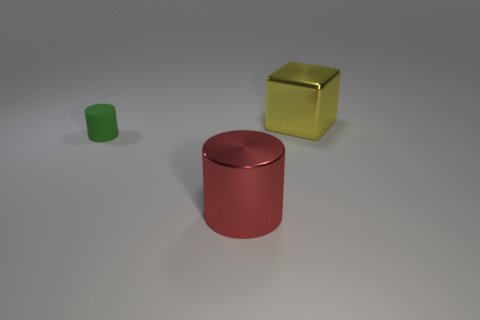How many other things are made of the same material as the big block?
Your answer should be very brief. 1. There is a object that is behind the red metallic cylinder and right of the small matte cylinder; what is its shape?
Make the answer very short. Cube. What is the color of the big block that is the same material as the red thing?
Your answer should be compact. Yellow. Is the number of big yellow metal objects right of the shiny cube the same as the number of big things?
Provide a succinct answer. No. What shape is the other object that is the same size as the red metallic object?
Offer a terse response. Cube. What number of other objects are the same shape as the green object?
Provide a short and direct response. 1. Is the size of the yellow block the same as the cylinder that is on the left side of the red cylinder?
Your answer should be compact. No. What number of objects are big metal objects that are to the left of the large yellow metallic object or small blue rubber cylinders?
Offer a terse response. 1. What shape is the big metal thing that is on the left side of the big yellow metal cube?
Provide a short and direct response. Cylinder. Is the number of large red things to the right of the big metal cube the same as the number of metal objects that are on the left side of the green object?
Your response must be concise. Yes. 